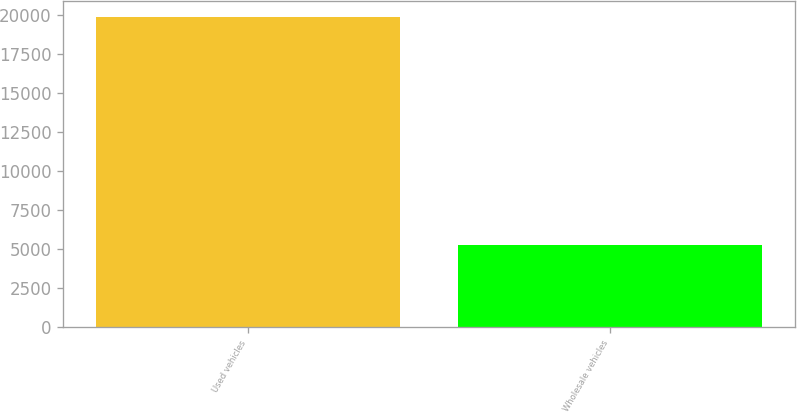Convert chart. <chart><loc_0><loc_0><loc_500><loc_500><bar_chart><fcel>Used vehicles<fcel>Wholesale vehicles<nl><fcel>19897<fcel>5273<nl></chart> 